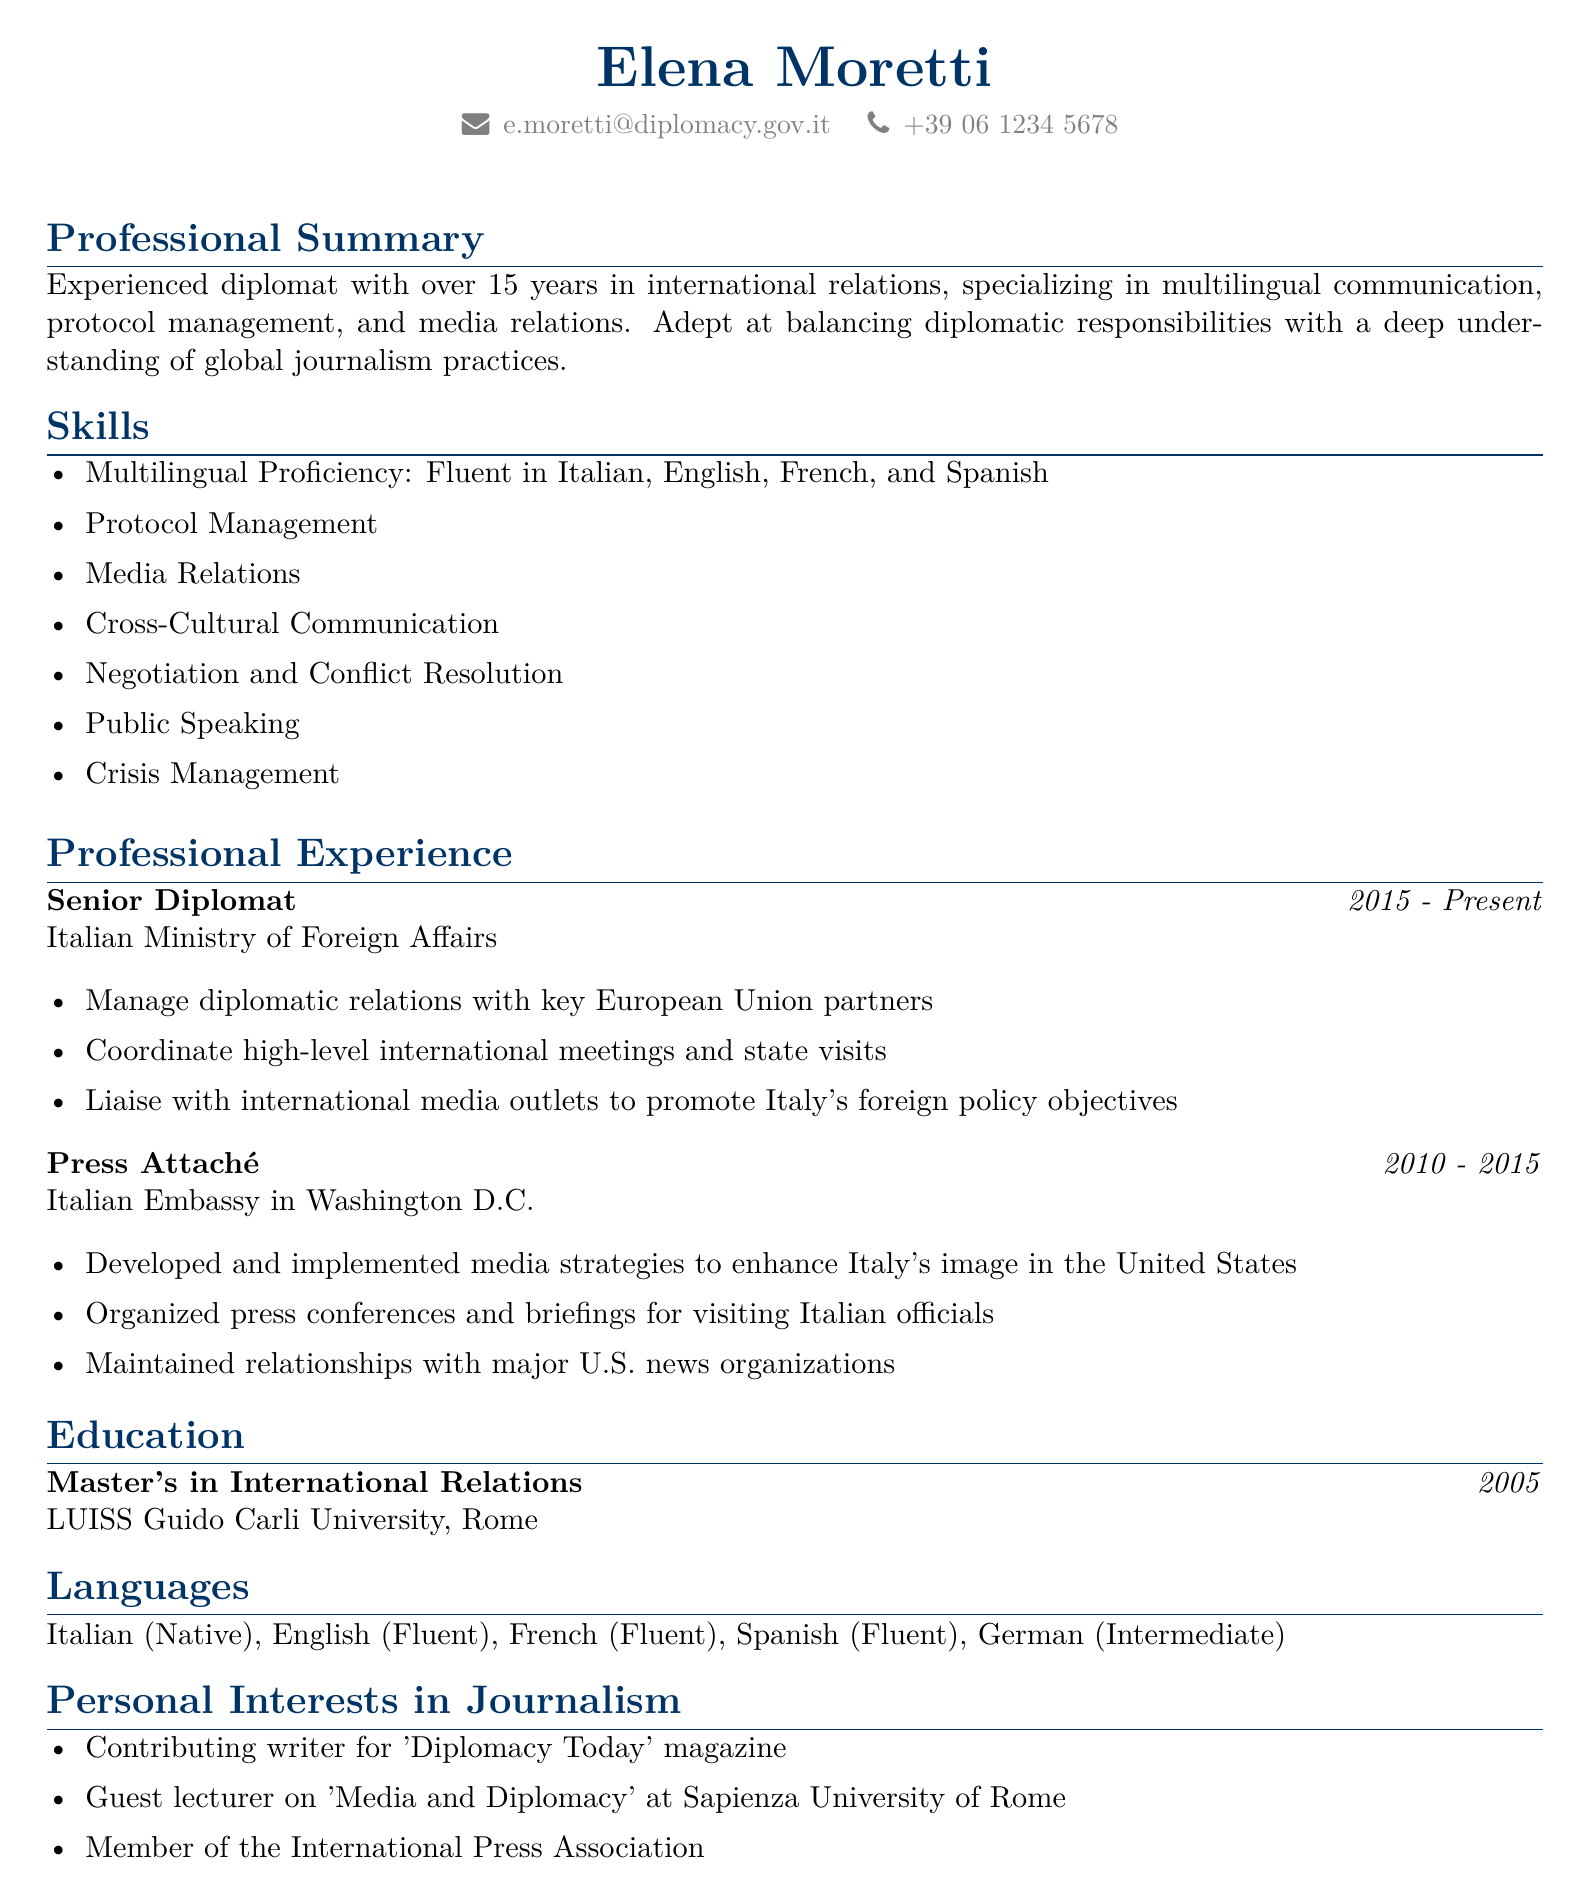What is Elena Moretti's email address? The email address provided in the document is Elena Moretti's contact information.
Answer: e.moretti@diplomacy.gov.it What languages is Elena Moretti fluent in? The document lists Elena Moretti's language proficiency, specifying her fluency levels.
Answer: Italian, English, French, Spanish What is Elena Moretti's current job title? The job title for her position is included under professional experience.
Answer: Senior Diplomat How long has Elena Moretti been working at the Italian Ministry of Foreign Affairs? The document outlines her professional experience and the duration of her current role.
Answer: Since 2015 What degree did Elena Moretti obtain? The educational background includes details of her highest degree earned and the corresponding institution.
Answer: Master's in International Relations What role did Elena Moretti hold from 2010 to 2015? This question pertains to the professional experience section, highlighting her past job title.
Answer: Press Attaché Which magazine does Elena Moretti contribute to? The personal interests section outlines her contributions to journalism.
Answer: Diplomacy Today What topic does Elena Moretti lecture on at Sapienza University of Rome? The personal interests section specifies the subject matter of her guest lectures.
Answer: Media and Diplomacy 